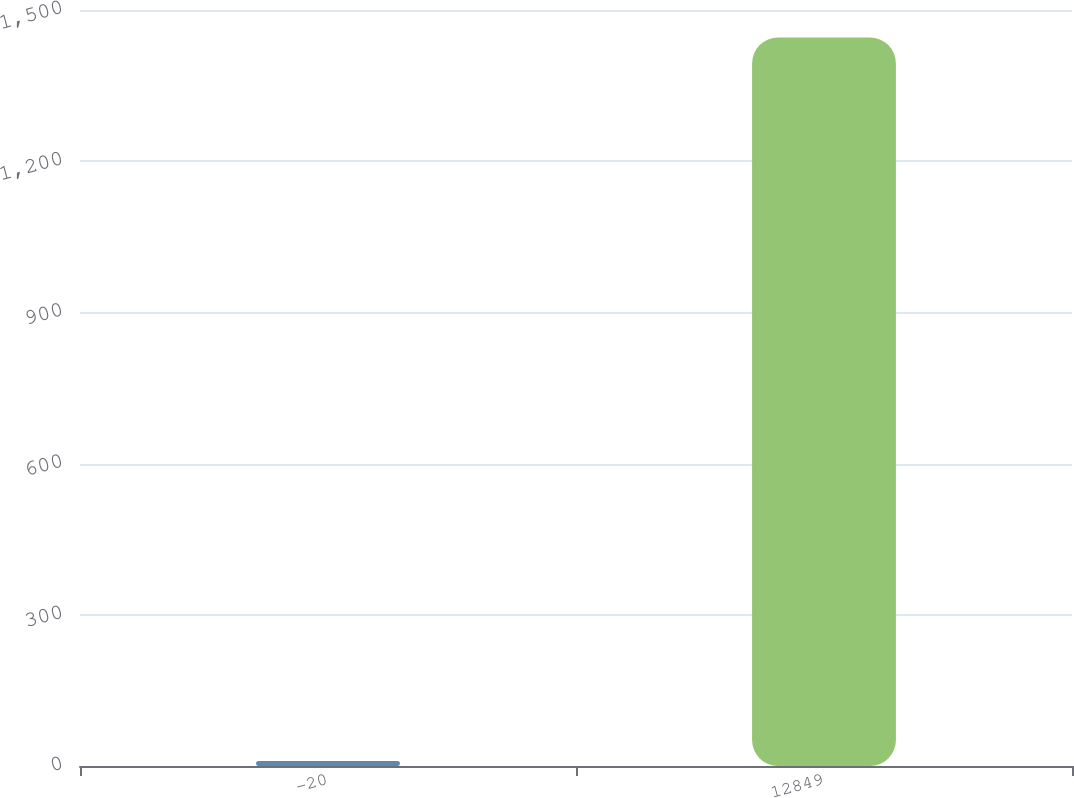Convert chart to OTSL. <chart><loc_0><loc_0><loc_500><loc_500><bar_chart><fcel>-20<fcel>12849<nl><fcel>10<fcel>1445.5<nl></chart> 